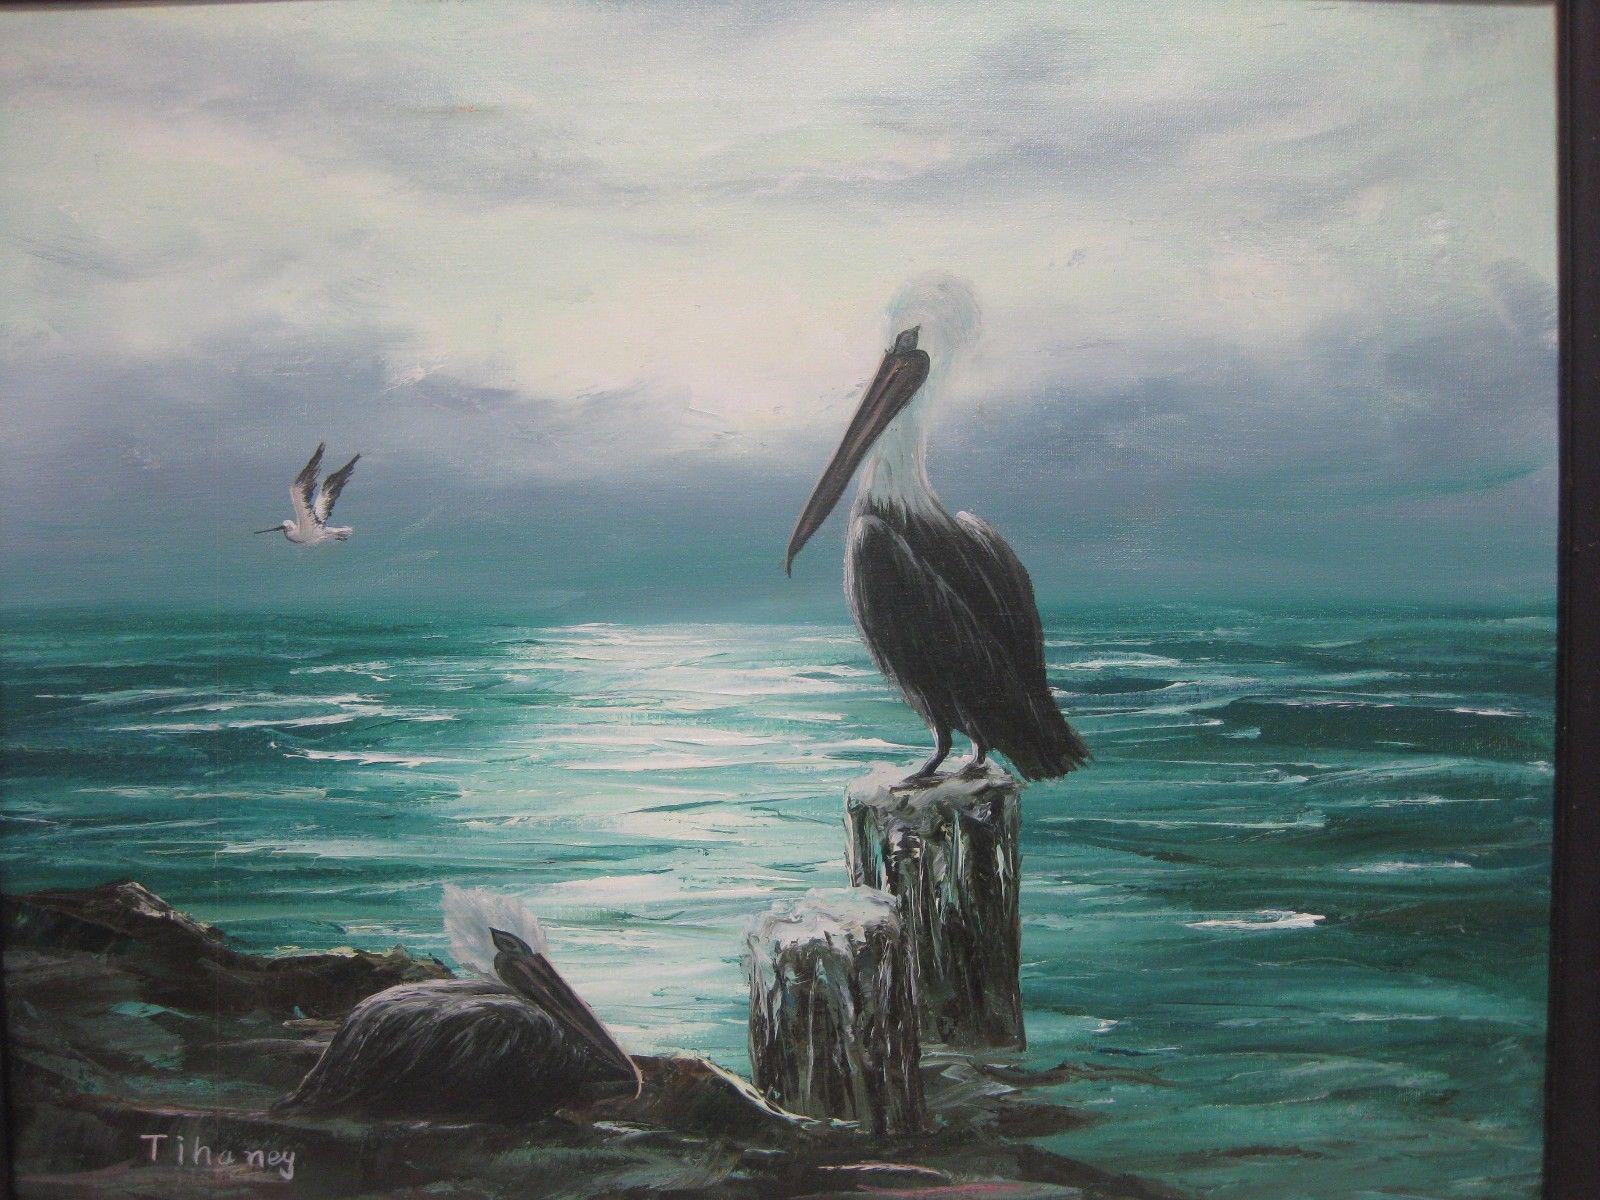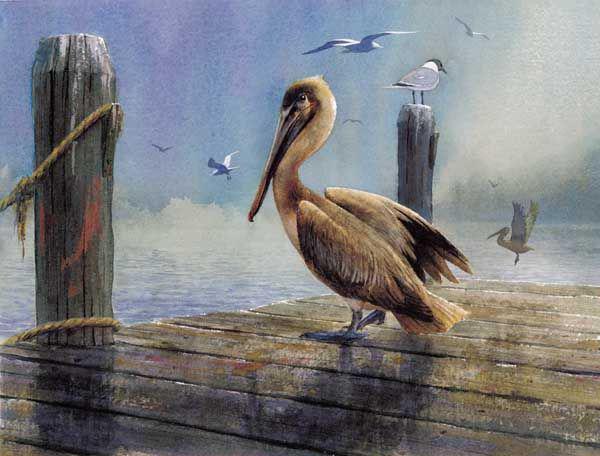The first image is the image on the left, the second image is the image on the right. Assess this claim about the two images: "One image includes a pelican and a smaller seabird perched on some part of a wooden pier.". Correct or not? Answer yes or no. Yes. The first image is the image on the left, the second image is the image on the right. For the images displayed, is the sentence "A single pelican sits on a post in one of the image." factually correct? Answer yes or no. Yes. 